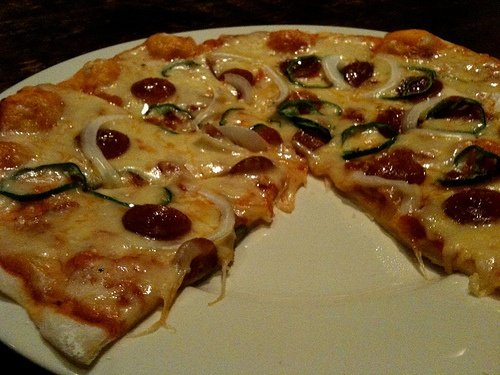Describe the objects in this image and their specific colors. I can see pizza in black, olive, and maroon tones and pizza in black, olive, and maroon tones in this image. 